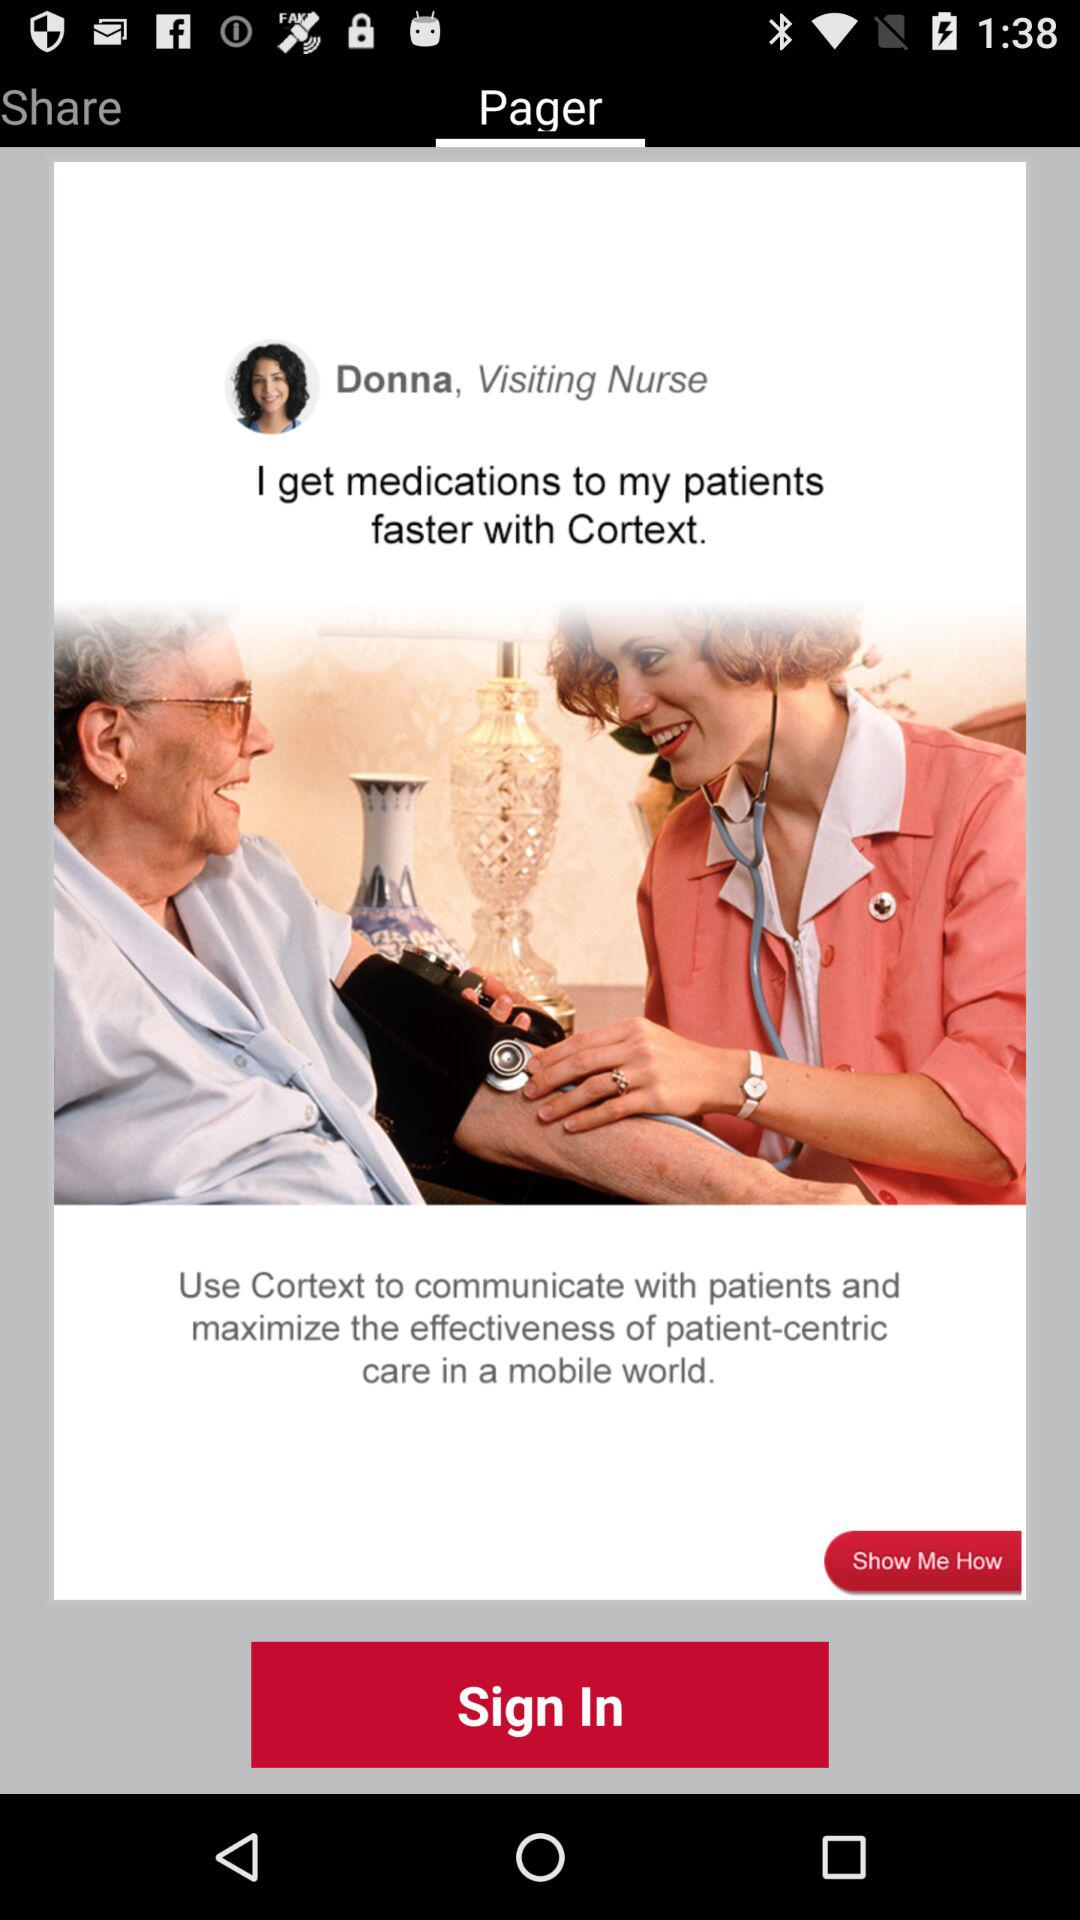What can we use to communicate with patients? You can use "Cortext" to communicate with patients. 